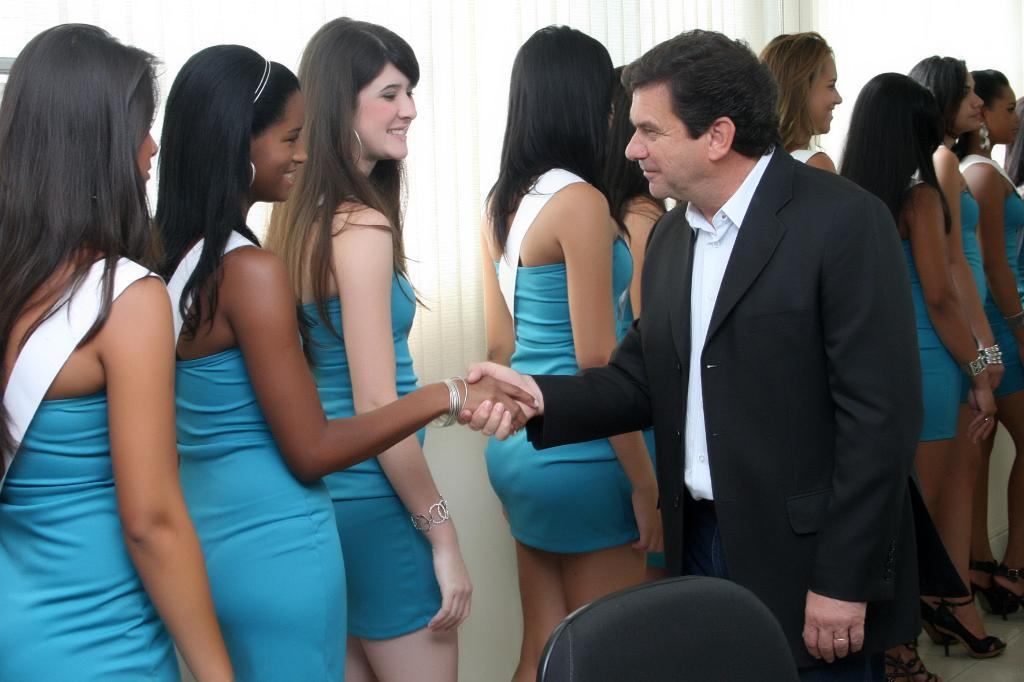What is happening in the foreground of the image? A person is shaking hands with another person in the foreground. What can be seen behind the group of people? There is a wall behind the people. Is there any additional decoration or feature associated with the wall? Yes, there is a curtain associated with the wall. What object is located in the foreground of the image? There is a chair in the foreground of the image. What type of cake is being served to the north of the group of people? There is no cake present in the image, and the concept of "north" is not relevant to the image. 